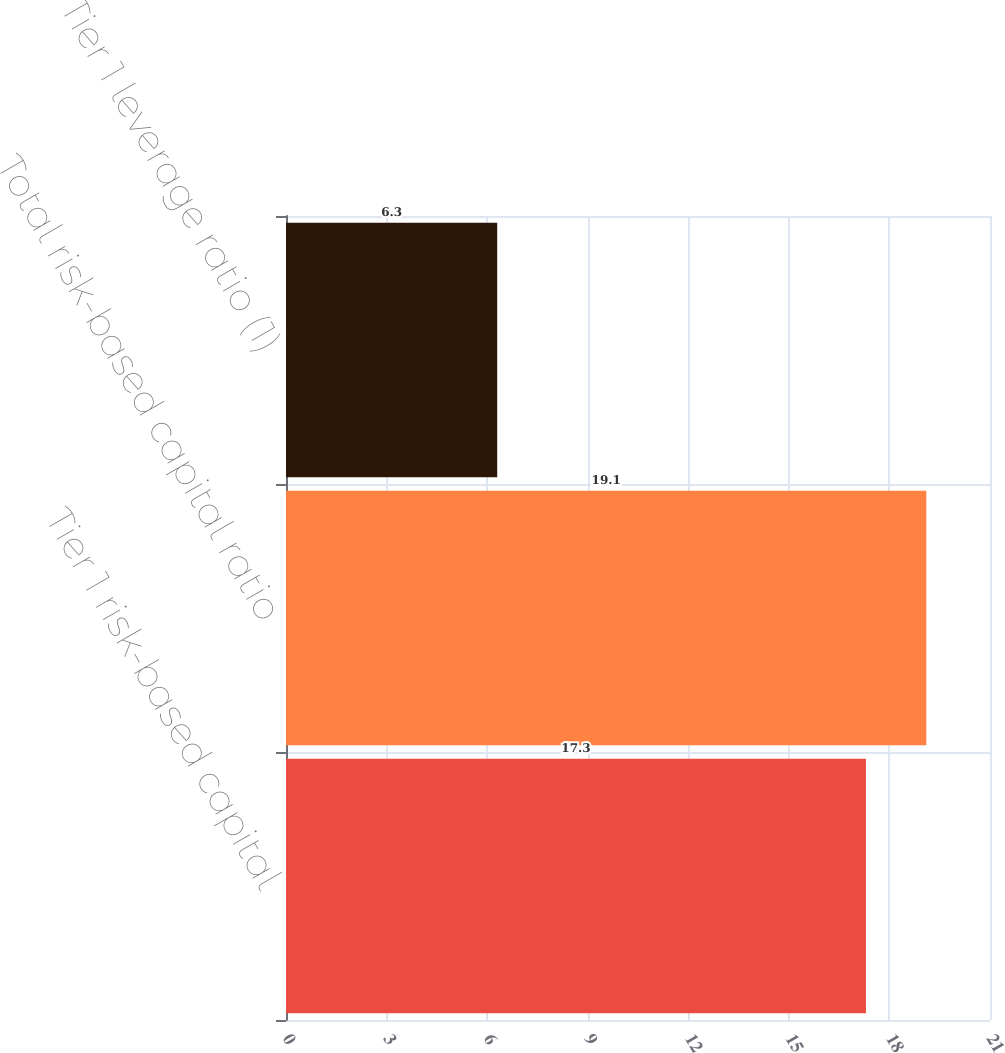Convert chart to OTSL. <chart><loc_0><loc_0><loc_500><loc_500><bar_chart><fcel>Tier 1 risk-based capital<fcel>Total risk-based capital ratio<fcel>Tier 1 leverage ratio (1)<nl><fcel>17.3<fcel>19.1<fcel>6.3<nl></chart> 